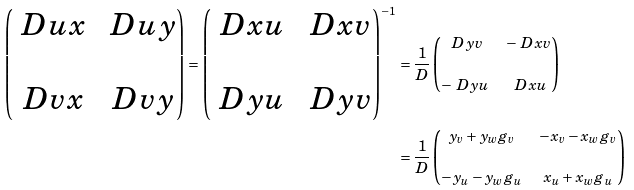<formula> <loc_0><loc_0><loc_500><loc_500>\left ( \begin{matrix} \ D { u } { x } & \ D { u } { y } \\ \\ \ D { v } { x } & \ D { v } { y } \end{matrix} \right ) = \left ( \begin{matrix} \ D { x } { u } & \ D { x } { v } \\ \\ \ D { y } { u } & \ D { y } { v } \end{matrix} \right ) ^ { - 1 } & = \frac { 1 } { D } \left ( \begin{matrix} \ D { y } { v } & - \ D { x } { v } \\ \\ - \ D { y } { u } & \ D { x } { u } \end{matrix} \right ) \\ & = \frac { 1 } { D } \left ( \begin{matrix} y _ { v } + y _ { w } g _ { v } & - x _ { v } - x _ { w } g _ { v } \\ \\ - y _ { u } - y _ { w } g _ { u } & x _ { u } + x _ { w } g _ { u } \end{matrix} \right )</formula> 